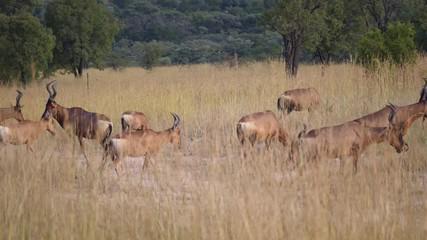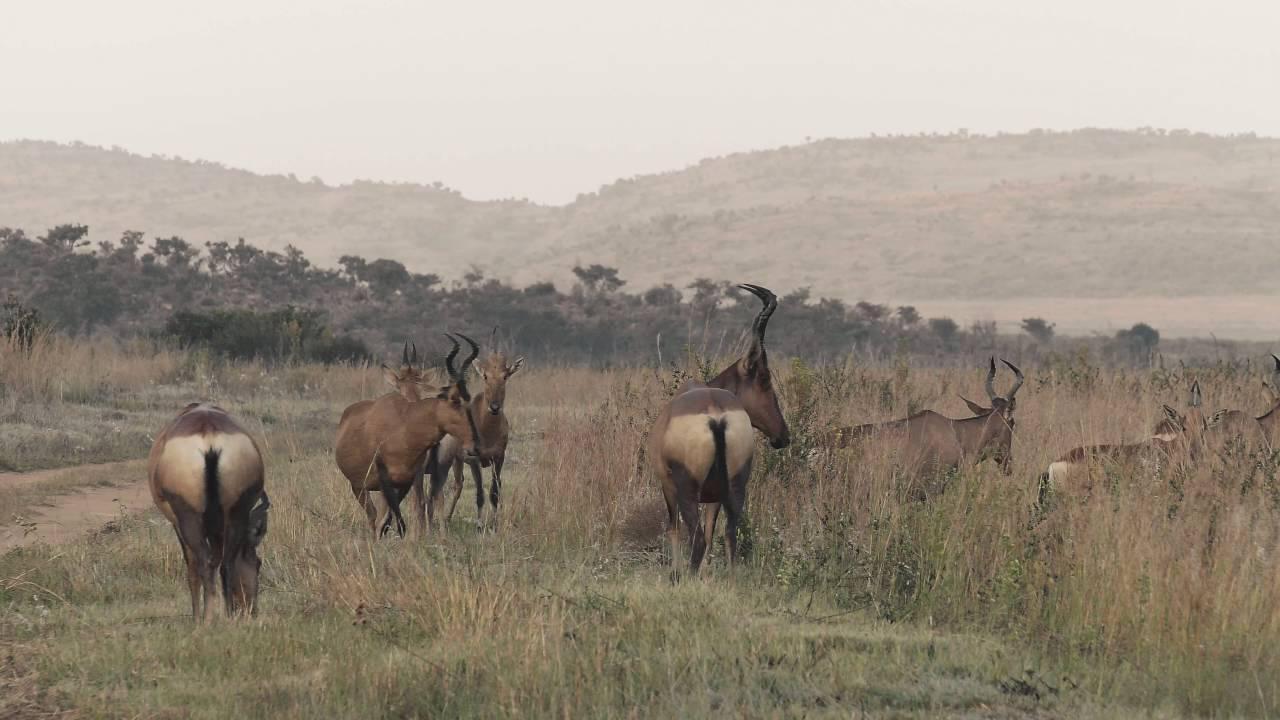The first image is the image on the left, the second image is the image on the right. For the images displayed, is the sentence "There are at most 6 antelopes in at least one of the images." factually correct? Answer yes or no. No. The first image is the image on the left, the second image is the image on the right. Analyze the images presented: Is the assertion "At least two horned animals are standing with their rears directly facing the camera, showing very dark tails on pale hinds." valid? Answer yes or no. Yes. 